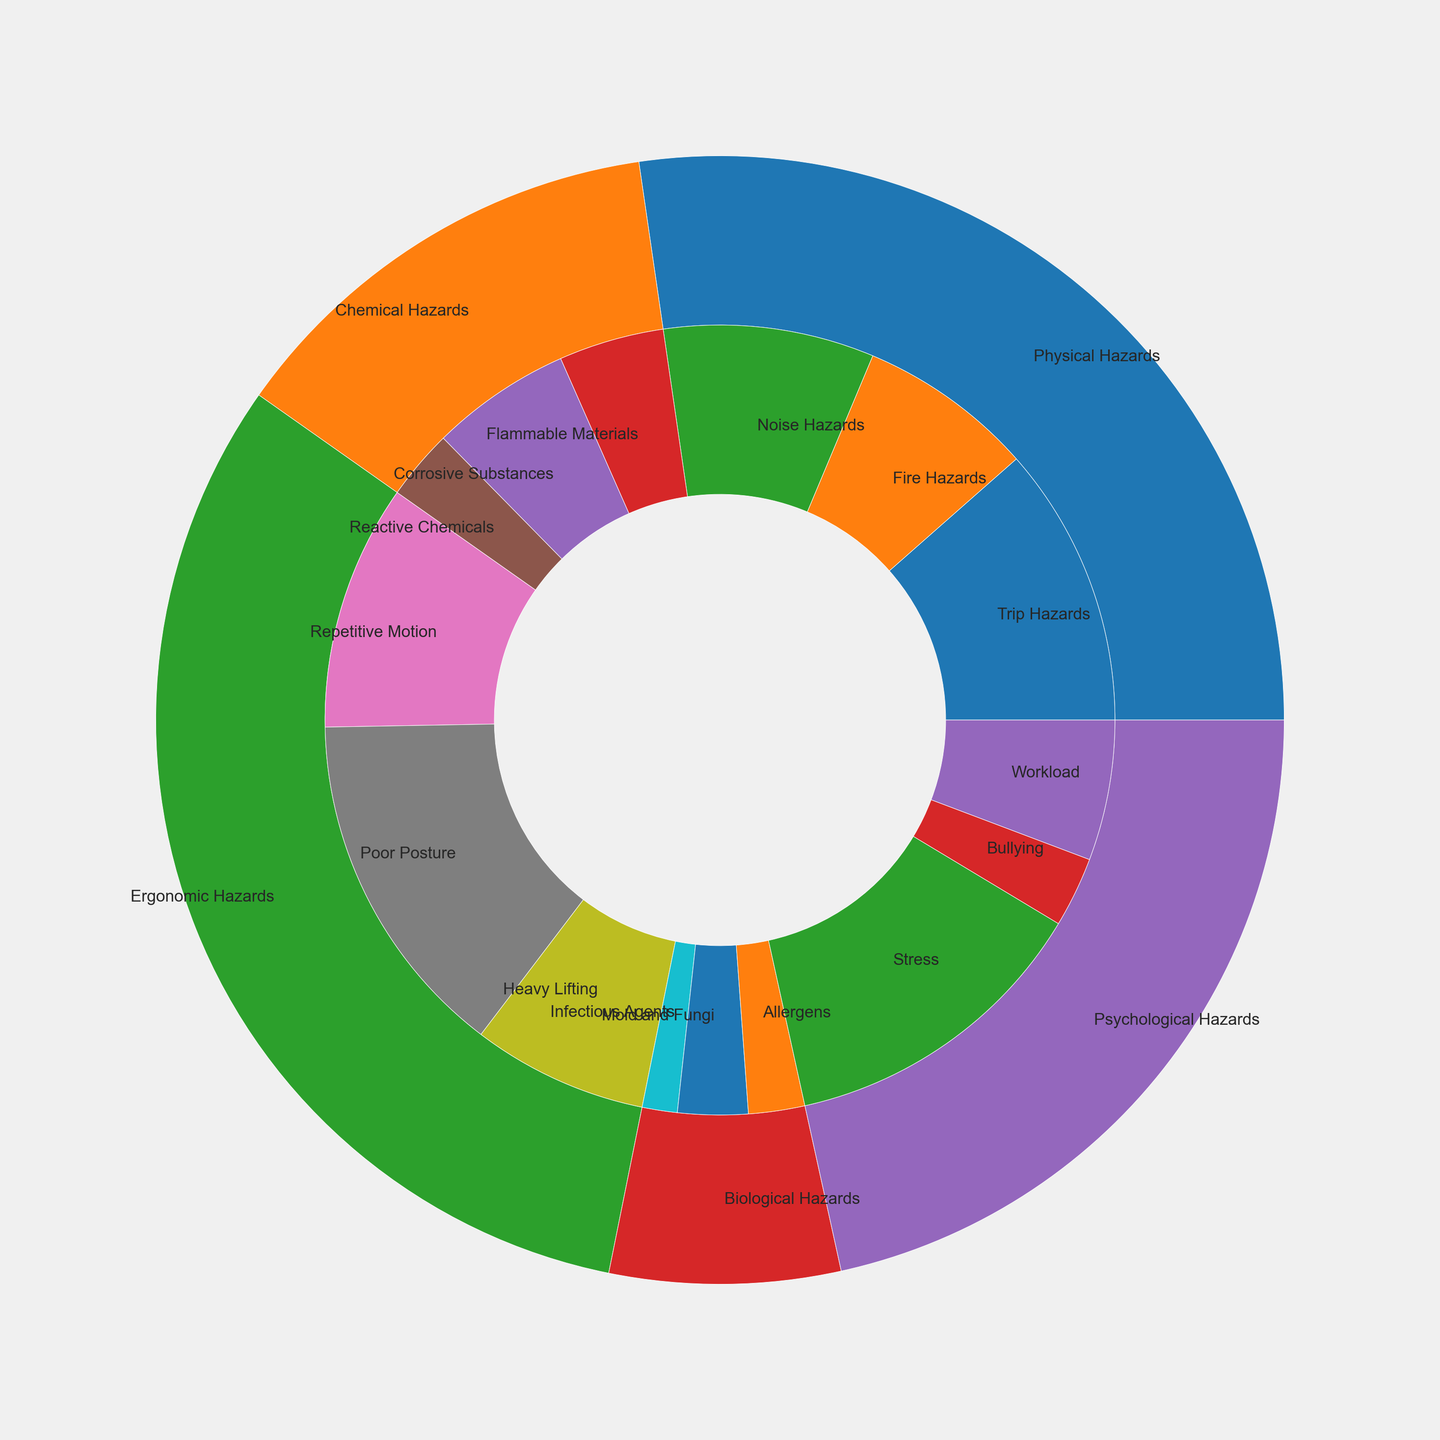What is the most common hazard subcategory? To determine the most common hazard subcategory, look for the largest slice in the inner ring of the nested pie chart. Identify the subcategory label associated with this slice.
Answer: Poor Posture Compare the total count of Physical Hazards and Psychological Hazards. Which is higher, and by how much? First, sum the counts of subcategories under Physical Hazards (40+25+30 = 95) and Psychological Hazards (45+10+20 = 75). Then, subtract the total of Psychological Hazards from Physical Hazards (95 - 75).
Answer: Physical Hazards, by 20 What proportion of the Physical Hazards are Fire Hazards? To find this proportion, divide the count of Fire Hazards by the total count of Physical Hazards: 25 / (40 + 25 + 30).
Answer: 25/95 or approximately 26.3% Which hazard category has the smallest representation, and what is its count? Look for the smallest slice in the outer ring of the nested pie chart, representing the hazard categories, and read the count corresponding to it.
Answer: Biological Hazards, 23 Is the count of Ergonomic Hazards greater than the combined count of Chemical and Biological Hazards? Sum the counts of Ergonomic Hazards subcategories (35+50+25 = 110) and the counts of Chemical Hazards (15+20+10 = 45) and Biological Hazards (5+10+8 = 23). Compare the two sums (110 vs. 68).
Answer: Yes Which color represents Psychological Hazards? Identify the color associated with the Psychological Hazards category label in the outer ring of the nested pie chart.
Answer: Blue How many more Trip Hazards are there compared to Bullying cases? Subtract the count of Bullying cases from the count of Trip Hazards (40 - 10).
Answer: 30 Which subcategory under Psychological Hazards has the highest count? Look at the slices within the Psychological Hazards section and find the largest one.
Answer: Stress What is the total count of counts for all hazard categories? Add the counts of all subcategories across every hazard category: (40 + 25 + 30 + 15 + 20 + 10 + 35 + 50 + 25 + 5 + 10 + 8 + 45 + 10 + 20).
Answer: 348 In the category of Chemical Hazards, which subcategory has the second highest count? Look at the subcategories within the Chemical Hazards section and find the one with the second largest slice.
Answer: Corrosive Substances 